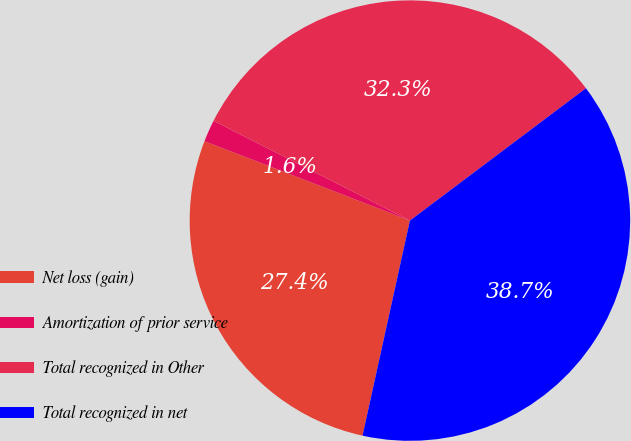<chart> <loc_0><loc_0><loc_500><loc_500><pie_chart><fcel>Net loss (gain)<fcel>Amortization of prior service<fcel>Total recognized in Other<fcel>Total recognized in net<nl><fcel>27.42%<fcel>1.61%<fcel>32.26%<fcel>38.71%<nl></chart> 